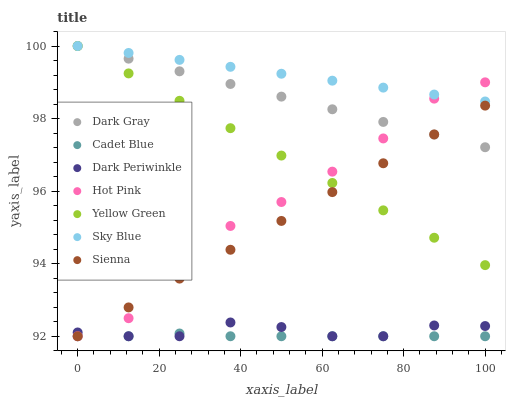Does Cadet Blue have the minimum area under the curve?
Answer yes or no. Yes. Does Sky Blue have the maximum area under the curve?
Answer yes or no. Yes. Does Yellow Green have the minimum area under the curve?
Answer yes or no. No. Does Yellow Green have the maximum area under the curve?
Answer yes or no. No. Is Yellow Green the smoothest?
Answer yes or no. Yes. Is Hot Pink the roughest?
Answer yes or no. Yes. Is Cadet Blue the smoothest?
Answer yes or no. No. Is Cadet Blue the roughest?
Answer yes or no. No. Does Sienna have the lowest value?
Answer yes or no. Yes. Does Yellow Green have the lowest value?
Answer yes or no. No. Does Sky Blue have the highest value?
Answer yes or no. Yes. Does Cadet Blue have the highest value?
Answer yes or no. No. Is Dark Periwinkle less than Yellow Green?
Answer yes or no. Yes. Is Sky Blue greater than Cadet Blue?
Answer yes or no. Yes. Does Sienna intersect Dark Gray?
Answer yes or no. Yes. Is Sienna less than Dark Gray?
Answer yes or no. No. Is Sienna greater than Dark Gray?
Answer yes or no. No. Does Dark Periwinkle intersect Yellow Green?
Answer yes or no. No. 